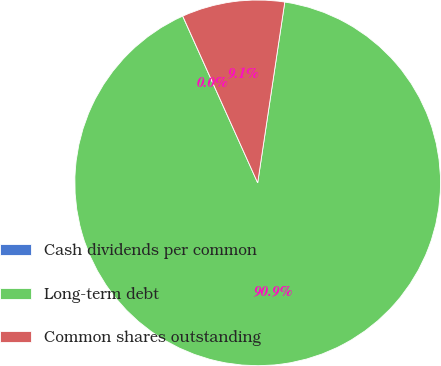Convert chart. <chart><loc_0><loc_0><loc_500><loc_500><pie_chart><fcel>Cash dividends per common<fcel>Long-term debt<fcel>Common shares outstanding<nl><fcel>0.01%<fcel>90.9%<fcel>9.09%<nl></chart> 